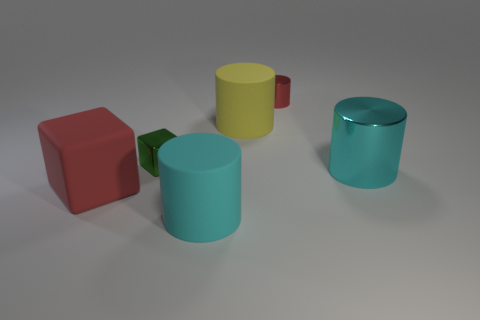Is there any other thing that is the same size as the cyan rubber object?
Ensure brevity in your answer.  Yes. There is a red object behind the red block; is its shape the same as the big metallic object?
Provide a succinct answer. Yes. Is the number of things in front of the yellow rubber thing greater than the number of small blue spheres?
Offer a terse response. Yes. The big object that is on the right side of the large object behind the small green shiny thing is what color?
Keep it short and to the point. Cyan. How many big purple rubber objects are there?
Provide a succinct answer. 0. What number of red objects are behind the large yellow matte cylinder and on the left side of the metallic cube?
Provide a succinct answer. 0. Is there anything else that is the same shape as the large red rubber object?
Keep it short and to the point. Yes. There is a small cylinder; is it the same color as the big matte thing that is left of the tiny shiny cube?
Give a very brief answer. Yes. There is a large matte thing on the left side of the large cyan matte cylinder; what is its shape?
Keep it short and to the point. Cube. How many other things are made of the same material as the large yellow cylinder?
Provide a short and direct response. 2. 